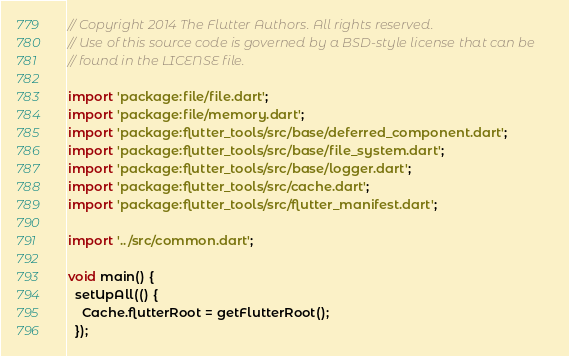<code> <loc_0><loc_0><loc_500><loc_500><_Dart_>// Copyright 2014 The Flutter Authors. All rights reserved.
// Use of this source code is governed by a BSD-style license that can be
// found in the LICENSE file.

import 'package:file/file.dart';
import 'package:file/memory.dart';
import 'package:flutter_tools/src/base/deferred_component.dart';
import 'package:flutter_tools/src/base/file_system.dart';
import 'package:flutter_tools/src/base/logger.dart';
import 'package:flutter_tools/src/cache.dart';
import 'package:flutter_tools/src/flutter_manifest.dart';

import '../src/common.dart';

void main() {
  setUpAll(() {
    Cache.flutterRoot = getFlutterRoot();
  });
</code> 